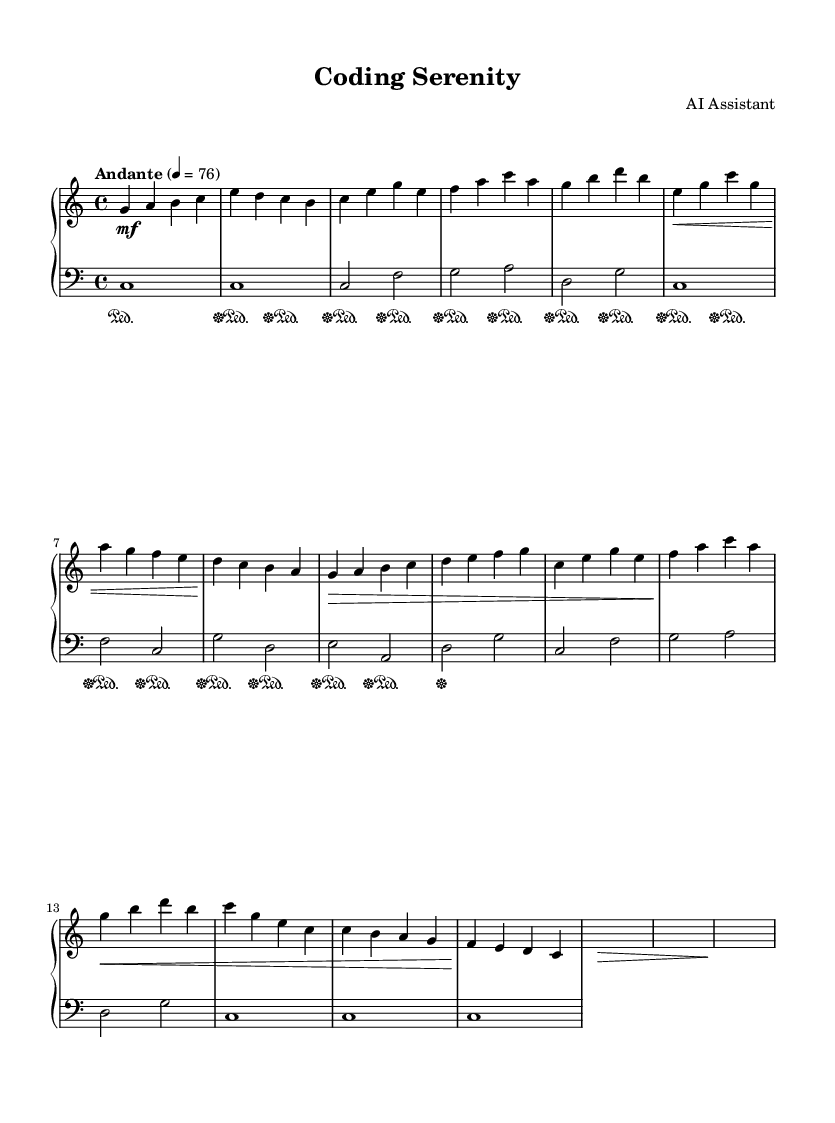What is the key signature of this music? The key signature is determined by looking at the beginning of the staff where there are no sharps or flats shown, indicating the piece is in a major scale with no accidentals. In this case, the key signature is C major.
Answer: C major What is the time signature of this music? The time signature is found at the beginning of the piece, represented by the numbers on the staff. Here, it shows 4 over 4, which means there are four beats in each measure and the quarter note gets one beat.
Answer: 4/4 What is the tempo marking of this music? The tempo marking is indicated in the header section which specifies the speed at which the music should be played. In this score, the tempo is marked as "Andante" followed by a metronome marking of 76.
Answer: Andante, 76 How many measures are there in the piece? To find the number of measures, I count each vertical line (bar line) on the staff. The score includes multiple measures, counted sequentially from the beginning to the end of the piece. In this score, there are 16 measures in total.
Answer: 16 What dynamic marking is used most frequently in this piece? The dynamics are notated above the staff; to find the marking used most frequently, I review the dynamics written throughout the piece. The marking "mf" (mezzo forte) appears at the start and continues frequently, indicating a moderate volume.
Answer: mf What instruments are indicated for this music? The instrument for each staff is specified by the "midiInstrument" property in the score. Both the right-hand and left-hand staves use "acoustic grand," which indicates the piano.
Answer: Acoustic grand 